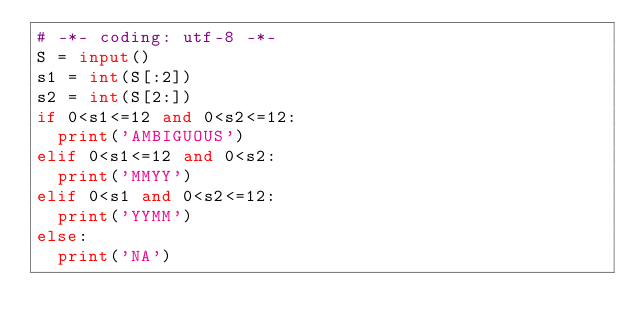<code> <loc_0><loc_0><loc_500><loc_500><_Python_># -*- coding: utf-8 -*-
S = input()
s1 = int(S[:2])
s2 = int(S[2:])
if 0<s1<=12 and 0<s2<=12:
  print('AMBIGUOUS')
elif 0<s1<=12 and 0<s2:
  print('MMYY')
elif 0<s1 and 0<s2<=12:
  print('YYMM')
else:
  print('NA')

</code> 